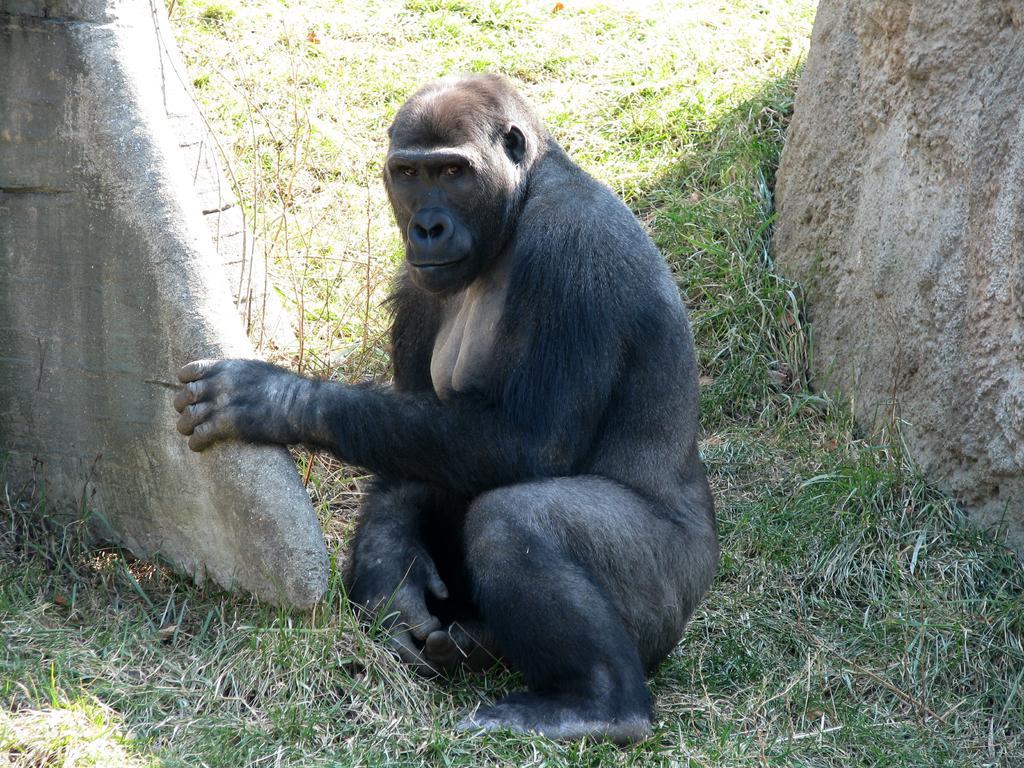Can you describe this image briefly? In the center of the image there is a chimpanzee. At the bottom of the image there is grass. To the both sides of the image there are stones. 